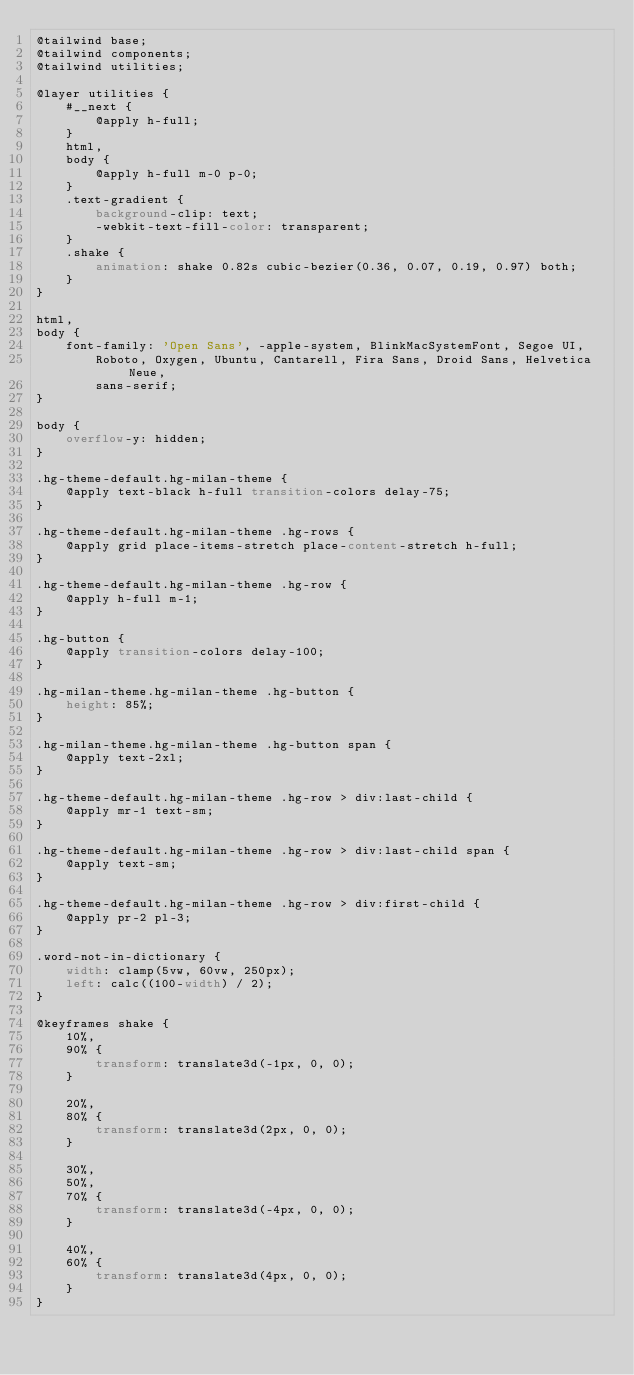<code> <loc_0><loc_0><loc_500><loc_500><_CSS_>@tailwind base;
@tailwind components;
@tailwind utilities;

@layer utilities {
    #__next {
        @apply h-full;
    }
    html,
    body {
        @apply h-full m-0 p-0;
    }
    .text-gradient {
        background-clip: text;
        -webkit-text-fill-color: transparent;
    }
    .shake {
        animation: shake 0.82s cubic-bezier(0.36, 0.07, 0.19, 0.97) both;
    }
}

html,
body {
    font-family: 'Open Sans', -apple-system, BlinkMacSystemFont, Segoe UI,
        Roboto, Oxygen, Ubuntu, Cantarell, Fira Sans, Droid Sans, Helvetica Neue,
        sans-serif;
}

body {
    overflow-y: hidden;
}

.hg-theme-default.hg-milan-theme {
    @apply text-black h-full transition-colors delay-75;
}

.hg-theme-default.hg-milan-theme .hg-rows {
    @apply grid place-items-stretch place-content-stretch h-full;
}

.hg-theme-default.hg-milan-theme .hg-row {
    @apply h-full m-1;
}

.hg-button {
    @apply transition-colors delay-100;
}

.hg-milan-theme.hg-milan-theme .hg-button {
    height: 85%;
}

.hg-milan-theme.hg-milan-theme .hg-button span {
    @apply text-2xl;
}

.hg-theme-default.hg-milan-theme .hg-row > div:last-child {
    @apply mr-1 text-sm;
}

.hg-theme-default.hg-milan-theme .hg-row > div:last-child span {
    @apply text-sm;
}

.hg-theme-default.hg-milan-theme .hg-row > div:first-child {
    @apply pr-2 pl-3;
}

.word-not-in-dictionary {
    width: clamp(5vw, 60vw, 250px);
    left: calc((100-width) / 2);
}

@keyframes shake {
    10%,
    90% {
        transform: translate3d(-1px, 0, 0);
    }

    20%,
    80% {
        transform: translate3d(2px, 0, 0);
    }

    30%,
    50%,
    70% {
        transform: translate3d(-4px, 0, 0);
    }

    40%,
    60% {
        transform: translate3d(4px, 0, 0);
    }
}
</code> 